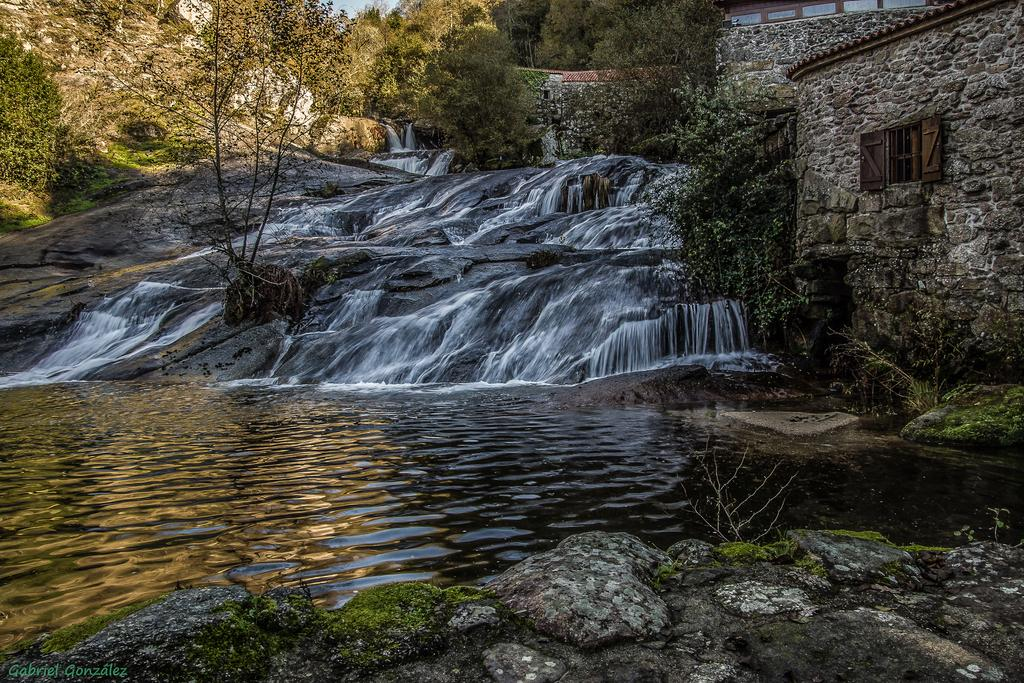What type of natural elements can be seen in the image? There are trees and plants in the image. What is the main feature in the middle of the image? There is a waterfall in the middle of the image. What is located on the right side of the image? There is a wall and a window on the right side of the image. What type of metal can be seen in the image? There is no specific metal mentioned or visible in the image. 